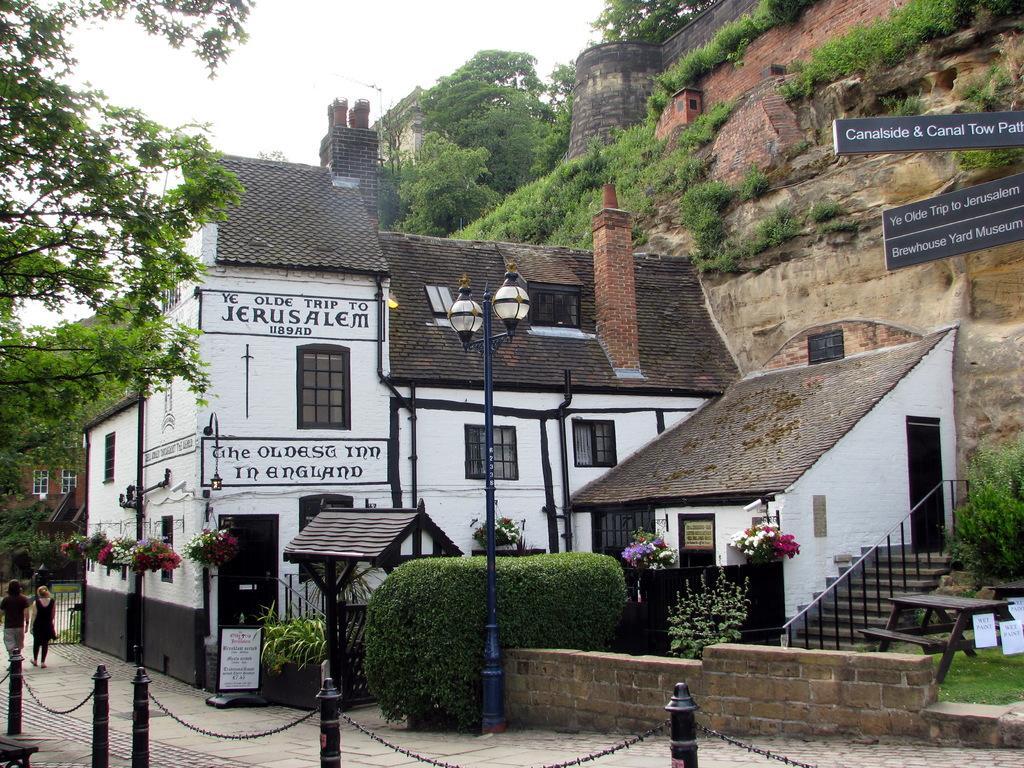Describe this image in one or two sentences. There are two people walking and we can see plants,poles,chains,boards,lights on pole,tree,bench,grass,table and building. In the background we can see trees,windows,wall,plants and sky. 